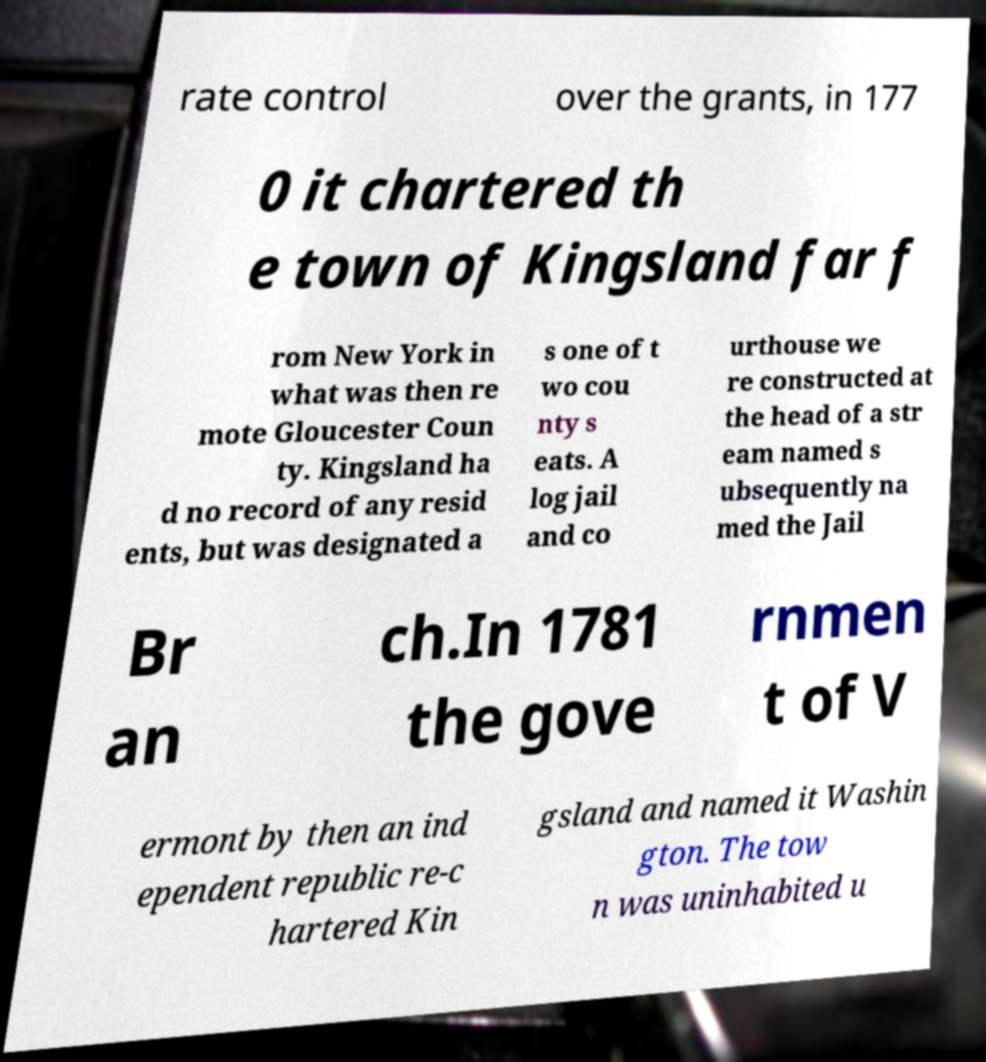Please identify and transcribe the text found in this image. rate control over the grants, in 177 0 it chartered th e town of Kingsland far f rom New York in what was then re mote Gloucester Coun ty. Kingsland ha d no record of any resid ents, but was designated a s one of t wo cou nty s eats. A log jail and co urthouse we re constructed at the head of a str eam named s ubsequently na med the Jail Br an ch.In 1781 the gove rnmen t of V ermont by then an ind ependent republic re-c hartered Kin gsland and named it Washin gton. The tow n was uninhabited u 